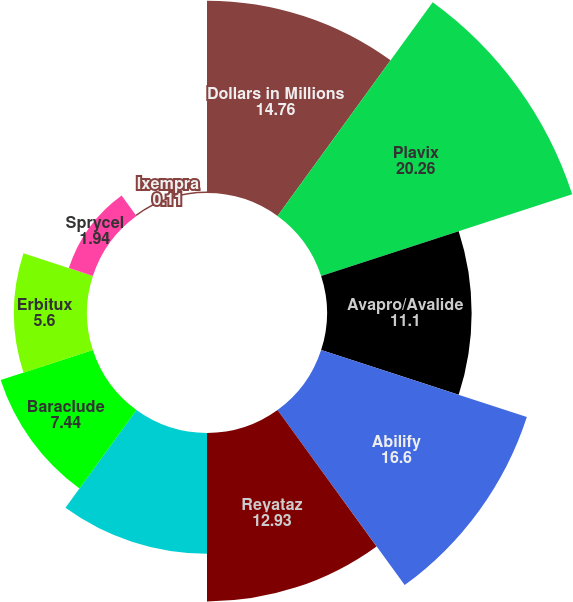Convert chart to OTSL. <chart><loc_0><loc_0><loc_500><loc_500><pie_chart><fcel>Dollars in Millions<fcel>Plavix<fcel>Avapro/Avalide<fcel>Abilify<fcel>Reyataz<fcel>Sustiva Franchise (total<fcel>Baraclude<fcel>Erbitux<fcel>Sprycel<fcel>Ixempra<nl><fcel>14.76%<fcel>20.26%<fcel>11.1%<fcel>16.6%<fcel>12.93%<fcel>9.27%<fcel>7.44%<fcel>5.6%<fcel>1.94%<fcel>0.11%<nl></chart> 